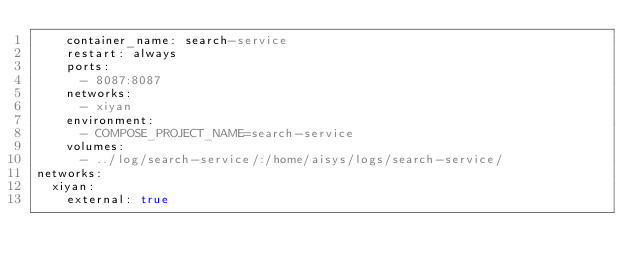Convert code to text. <code><loc_0><loc_0><loc_500><loc_500><_YAML_>    container_name: search-service
    restart: always
    ports:
      - 8087:8087
    networks:
      - xiyan
    environment:
      - COMPOSE_PROJECT_NAME=search-service
    volumes:
      - ../log/search-service/:/home/aisys/logs/search-service/
networks:
  xiyan:
    external: true
</code> 